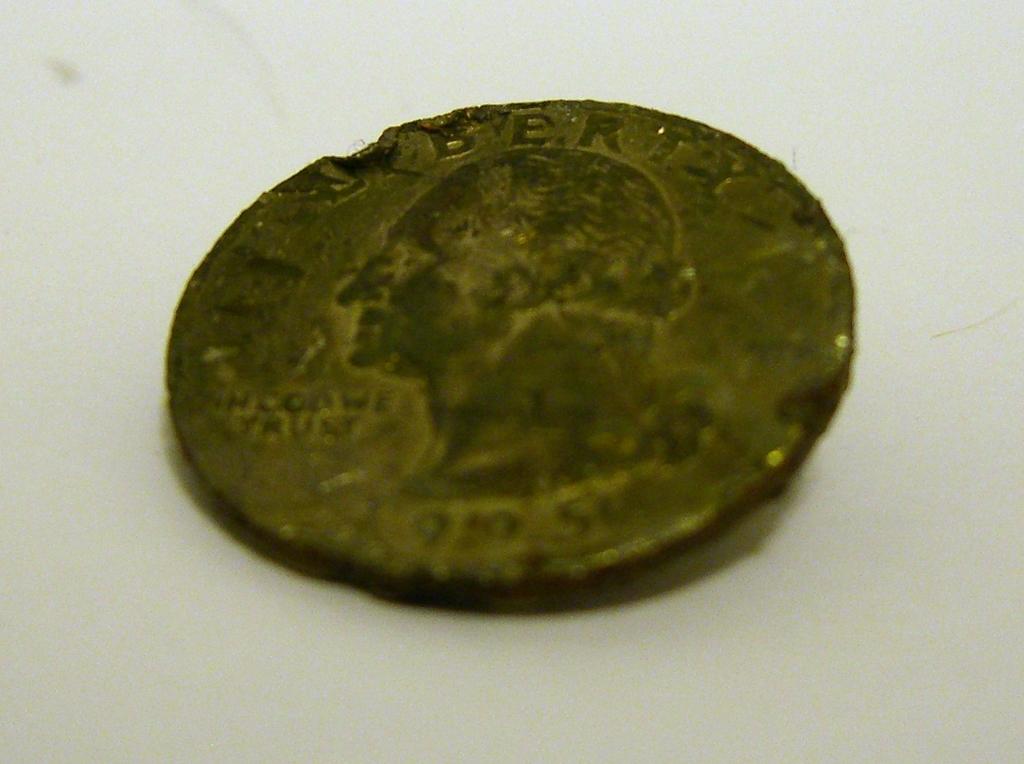What is the text under the chin of the man on the coin?
Ensure brevity in your answer.  In god we trust. 